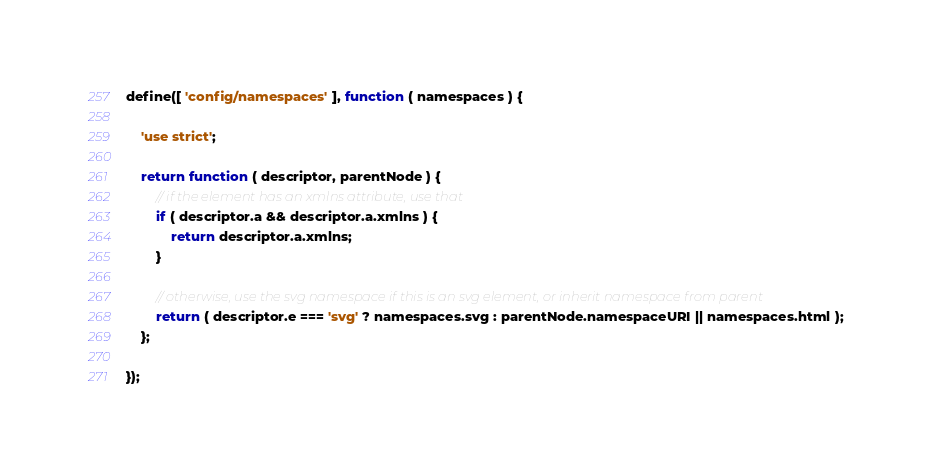Convert code to text. <code><loc_0><loc_0><loc_500><loc_500><_JavaScript_>define([ 'config/namespaces' ], function ( namespaces ) {

	'use strict';

	return function ( descriptor, parentNode ) {
		// if the element has an xmlns attribute, use that
		if ( descriptor.a && descriptor.a.xmlns ) {
			return descriptor.a.xmlns;
		}

		// otherwise, use the svg namespace if this is an svg element, or inherit namespace from parent
		return ( descriptor.e === 'svg' ? namespaces.svg : parentNode.namespaceURI || namespaces.html );
	};

});</code> 